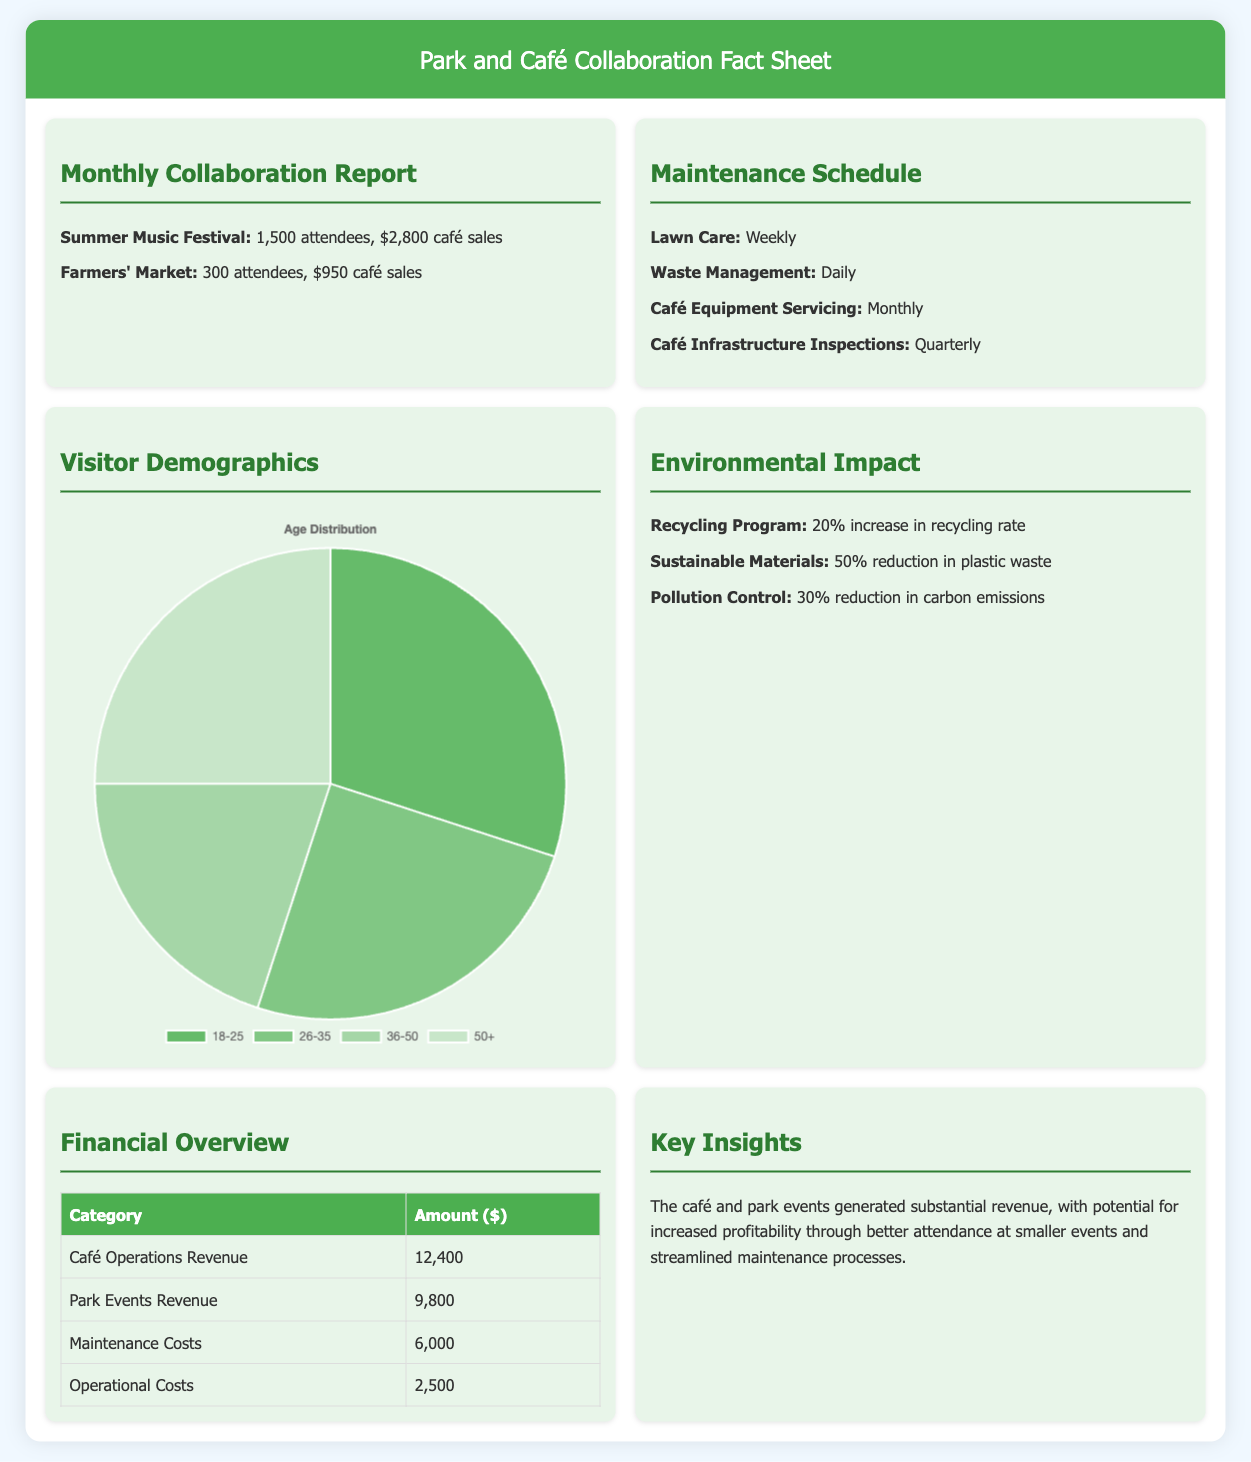What is the attendance for the Summer Music Festival? The attendance figure for the Summer Music Festival is mentioned in the report, which is 1,500 attendees.
Answer: 1,500 attendees How much in café sales did the Farmers' Market generate? The document states the café sales for the Farmers' Market, which is $950.
Answer: $950 What is the frequency of lawn care maintenance? The document specifies that lawn care is performed weekly.
Answer: Weekly What percentage increase was seen in the recycling rate? The document indicates a 20% increase in the recycling rate associated with the eco-friendly initiatives.
Answer: 20% What is the total revenue from café operations and park events? The revenue from café operations is $12,400 and from park events is $9,800, combining for a total of $22,200.
Answer: $22,200 Which demographic group has the highest percentage of visitors? The demographics chart indicates that the age group 18-25 holds the highest percentage at 30%.
Answer: 18-25 How often are café infrastructure inspections conducted? The document details that café infrastructure inspections occur quarterly.
Answer: Quarterly What is one area identified for potential cost savings? The document mentions that better attendance at smaller events is an area for potential cost savings.
Answer: Better attendance at smaller events 